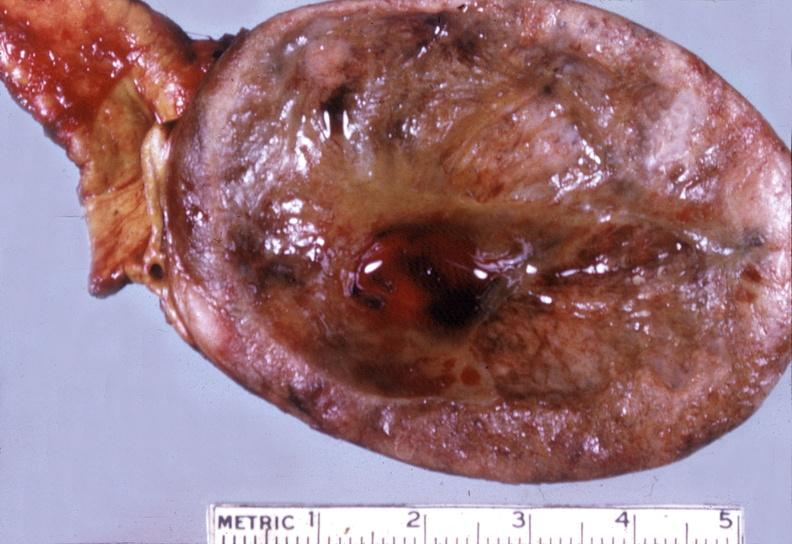what is present?
Answer the question using a single word or phrase. Endocrine 